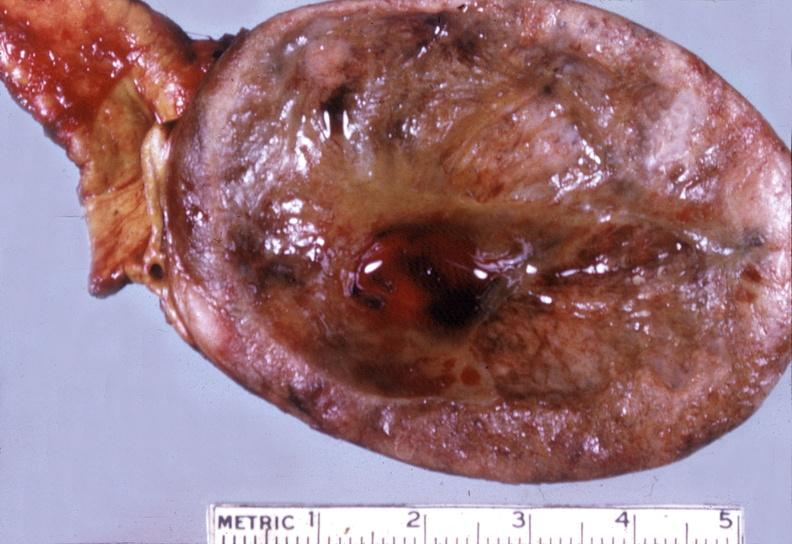what is present?
Answer the question using a single word or phrase. Endocrine 